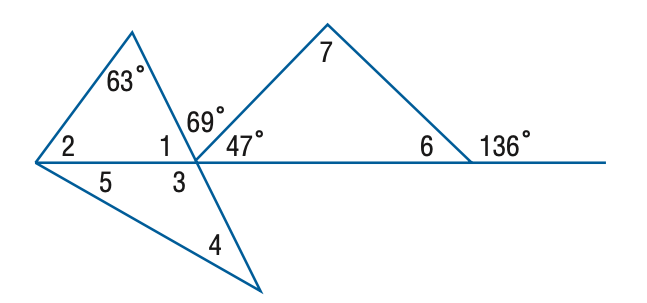Answer the mathemtical geometry problem and directly provide the correct option letter.
Question: Find the measure of \angle 5 if m \angle 4 = m \angle 5.
Choices: A: 32 B: 42 C: 44 D: 53 A 